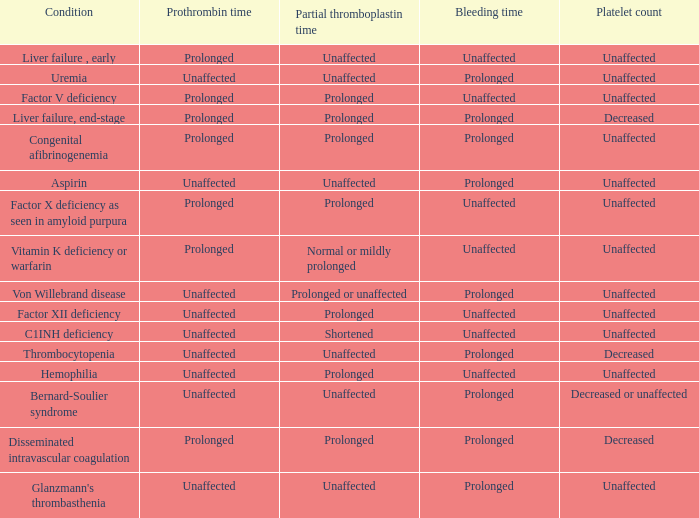Could you help me parse every detail presented in this table? {'header': ['Condition', 'Prothrombin time', 'Partial thromboplastin time', 'Bleeding time', 'Platelet count'], 'rows': [['Liver failure , early', 'Prolonged', 'Unaffected', 'Unaffected', 'Unaffected'], ['Uremia', 'Unaffected', 'Unaffected', 'Prolonged', 'Unaffected'], ['Factor V deficiency', 'Prolonged', 'Prolonged', 'Unaffected', 'Unaffected'], ['Liver failure, end-stage', 'Prolonged', 'Prolonged', 'Prolonged', 'Decreased'], ['Congenital afibrinogenemia', 'Prolonged', 'Prolonged', 'Prolonged', 'Unaffected'], ['Aspirin', 'Unaffected', 'Unaffected', 'Prolonged', 'Unaffected'], ['Factor X deficiency as seen in amyloid purpura', 'Prolonged', 'Prolonged', 'Unaffected', 'Unaffected'], ['Vitamin K deficiency or warfarin', 'Prolonged', 'Normal or mildly prolonged', 'Unaffected', 'Unaffected'], ['Von Willebrand disease', 'Unaffected', 'Prolonged or unaffected', 'Prolonged', 'Unaffected'], ['Factor XII deficiency', 'Unaffected', 'Prolonged', 'Unaffected', 'Unaffected'], ['C1INH deficiency', 'Unaffected', 'Shortened', 'Unaffected', 'Unaffected'], ['Thrombocytopenia', 'Unaffected', 'Unaffected', 'Prolonged', 'Decreased'], ['Hemophilia', 'Unaffected', 'Prolonged', 'Unaffected', 'Unaffected'], ['Bernard-Soulier syndrome', 'Unaffected', 'Unaffected', 'Prolonged', 'Decreased or unaffected'], ['Disseminated intravascular coagulation', 'Prolonged', 'Prolonged', 'Prolonged', 'Decreased'], ["Glanzmann's thrombasthenia", 'Unaffected', 'Unaffected', 'Prolonged', 'Unaffected']]} Which Condition has an unaffected Partial thromboplastin time, Platelet count, and a Prothrombin time? Aspirin, Uremia, Glanzmann's thrombasthenia. 